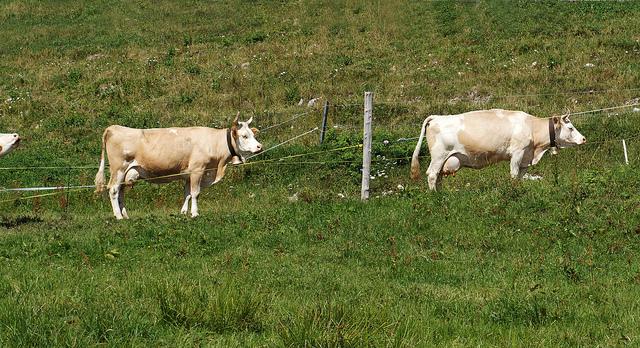Why are the cows wearing collars with little bells?
Quick response, please. Management. What is the color of the cow in front of the wall?
Answer briefly. Tan. What surface is the cow walking on?
Quick response, please. Grass. Where are the cowbells?
Give a very brief answer. Around cows' necks. How many cows are on the field?
Answer briefly. 2. How many cows are there?
Concise answer only. 3. 